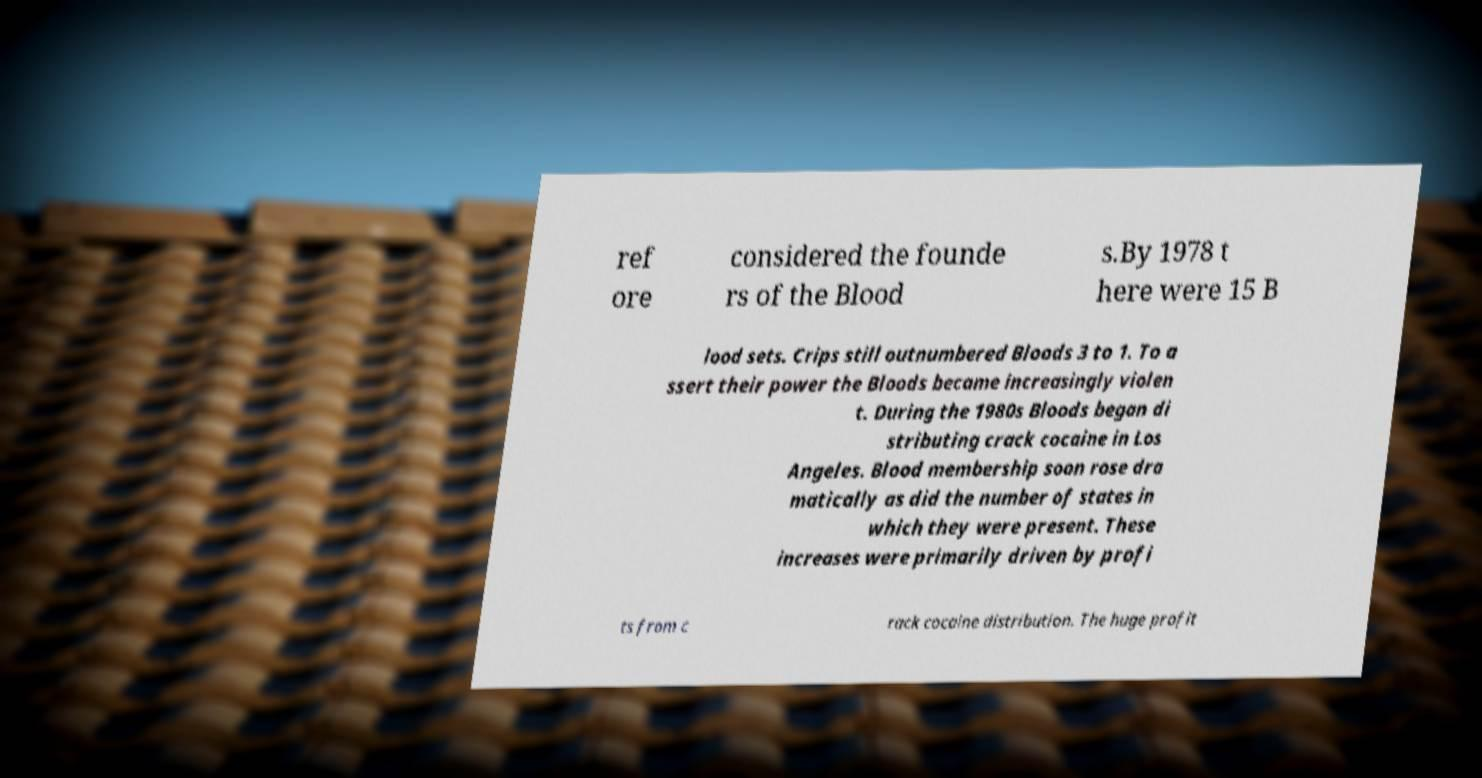Could you extract and type out the text from this image? ref ore considered the founde rs of the Blood s.By 1978 t here were 15 B lood sets. Crips still outnumbered Bloods 3 to 1. To a ssert their power the Bloods became increasingly violen t. During the 1980s Bloods began di stributing crack cocaine in Los Angeles. Blood membership soon rose dra matically as did the number of states in which they were present. These increases were primarily driven by profi ts from c rack cocaine distribution. The huge profit 